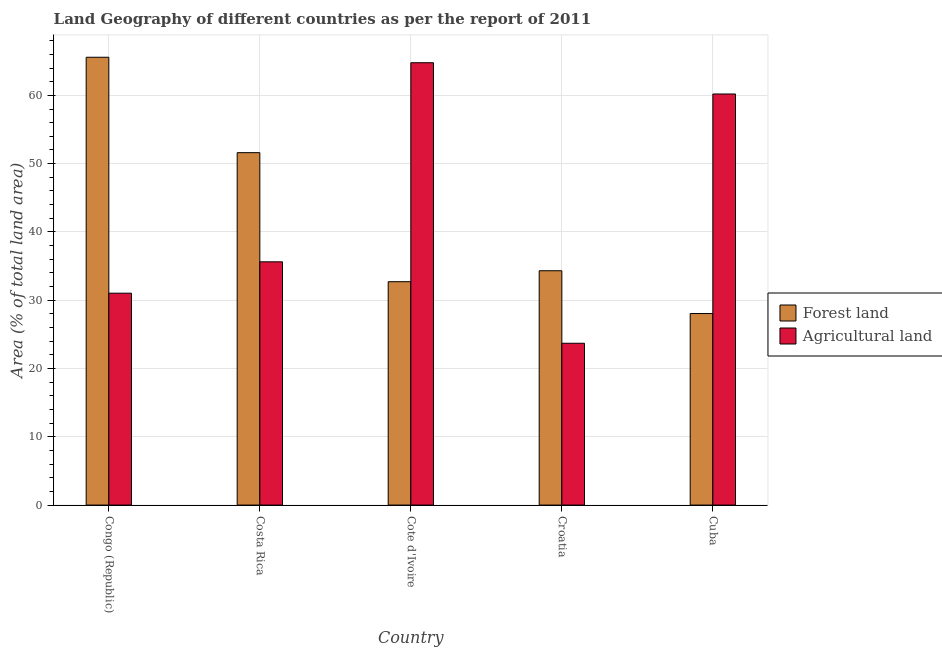How many groups of bars are there?
Give a very brief answer. 5. Are the number of bars per tick equal to the number of legend labels?
Offer a terse response. Yes. Are the number of bars on each tick of the X-axis equal?
Your answer should be very brief. Yes. How many bars are there on the 1st tick from the right?
Offer a terse response. 2. In how many cases, is the number of bars for a given country not equal to the number of legend labels?
Ensure brevity in your answer.  0. What is the percentage of land area under agriculture in Cote d'Ivoire?
Give a very brief answer. 64.78. Across all countries, what is the maximum percentage of land area under forests?
Your response must be concise. 65.58. Across all countries, what is the minimum percentage of land area under agriculture?
Offer a terse response. 23.7. In which country was the percentage of land area under forests maximum?
Give a very brief answer. Congo (Republic). In which country was the percentage of land area under agriculture minimum?
Provide a short and direct response. Croatia. What is the total percentage of land area under forests in the graph?
Provide a succinct answer. 212.27. What is the difference between the percentage of land area under agriculture in Congo (Republic) and that in Cuba?
Keep it short and to the point. -29.17. What is the difference between the percentage of land area under agriculture in Cuba and the percentage of land area under forests in Costa Rica?
Your answer should be compact. 8.59. What is the average percentage of land area under agriculture per country?
Make the answer very short. 43.07. What is the difference between the percentage of land area under forests and percentage of land area under agriculture in Congo (Republic)?
Make the answer very short. 34.55. What is the ratio of the percentage of land area under agriculture in Congo (Republic) to that in Croatia?
Offer a terse response. 1.31. Is the percentage of land area under agriculture in Congo (Republic) less than that in Costa Rica?
Keep it short and to the point. Yes. What is the difference between the highest and the second highest percentage of land area under agriculture?
Your response must be concise. 4.58. What is the difference between the highest and the lowest percentage of land area under agriculture?
Offer a terse response. 41.08. In how many countries, is the percentage of land area under forests greater than the average percentage of land area under forests taken over all countries?
Provide a short and direct response. 2. What does the 2nd bar from the left in Congo (Republic) represents?
Offer a terse response. Agricultural land. What does the 2nd bar from the right in Congo (Republic) represents?
Provide a succinct answer. Forest land. How many countries are there in the graph?
Your response must be concise. 5. What is the difference between two consecutive major ticks on the Y-axis?
Offer a very short reply. 10. Are the values on the major ticks of Y-axis written in scientific E-notation?
Provide a succinct answer. No. Does the graph contain any zero values?
Make the answer very short. No. Does the graph contain grids?
Make the answer very short. Yes. Where does the legend appear in the graph?
Make the answer very short. Center right. What is the title of the graph?
Give a very brief answer. Land Geography of different countries as per the report of 2011. Does "RDB concessional" appear as one of the legend labels in the graph?
Offer a terse response. No. What is the label or title of the X-axis?
Make the answer very short. Country. What is the label or title of the Y-axis?
Your answer should be very brief. Area (% of total land area). What is the Area (% of total land area) of Forest land in Congo (Republic)?
Your answer should be compact. 65.58. What is the Area (% of total land area) of Agricultural land in Congo (Republic)?
Provide a short and direct response. 31.03. What is the Area (% of total land area) in Forest land in Costa Rica?
Keep it short and to the point. 51.61. What is the Area (% of total land area) in Agricultural land in Costa Rica?
Your response must be concise. 35.62. What is the Area (% of total land area) of Forest land in Cote d'Ivoire?
Your answer should be very brief. 32.71. What is the Area (% of total land area) in Agricultural land in Cote d'Ivoire?
Offer a terse response. 64.78. What is the Area (% of total land area) of Forest land in Croatia?
Your answer should be compact. 34.32. What is the Area (% of total land area) in Agricultural land in Croatia?
Your response must be concise. 23.7. What is the Area (% of total land area) in Forest land in Cuba?
Offer a terse response. 28.05. What is the Area (% of total land area) of Agricultural land in Cuba?
Keep it short and to the point. 60.2. Across all countries, what is the maximum Area (% of total land area) of Forest land?
Provide a short and direct response. 65.58. Across all countries, what is the maximum Area (% of total land area) in Agricultural land?
Give a very brief answer. 64.78. Across all countries, what is the minimum Area (% of total land area) in Forest land?
Ensure brevity in your answer.  28.05. Across all countries, what is the minimum Area (% of total land area) of Agricultural land?
Your response must be concise. 23.7. What is the total Area (% of total land area) of Forest land in the graph?
Your answer should be very brief. 212.27. What is the total Area (% of total land area) of Agricultural land in the graph?
Provide a short and direct response. 215.33. What is the difference between the Area (% of total land area) of Forest land in Congo (Republic) and that in Costa Rica?
Provide a succinct answer. 13.97. What is the difference between the Area (% of total land area) of Agricultural land in Congo (Republic) and that in Costa Rica?
Provide a short and direct response. -4.6. What is the difference between the Area (% of total land area) in Forest land in Congo (Republic) and that in Cote d'Ivoire?
Your answer should be compact. 32.87. What is the difference between the Area (% of total land area) in Agricultural land in Congo (Republic) and that in Cote d'Ivoire?
Your answer should be very brief. -33.75. What is the difference between the Area (% of total land area) of Forest land in Congo (Republic) and that in Croatia?
Offer a terse response. 31.26. What is the difference between the Area (% of total land area) of Agricultural land in Congo (Republic) and that in Croatia?
Make the answer very short. 7.33. What is the difference between the Area (% of total land area) of Forest land in Congo (Republic) and that in Cuba?
Ensure brevity in your answer.  37.53. What is the difference between the Area (% of total land area) in Agricultural land in Congo (Republic) and that in Cuba?
Provide a succinct answer. -29.17. What is the difference between the Area (% of total land area) in Forest land in Costa Rica and that in Cote d'Ivoire?
Provide a short and direct response. 18.9. What is the difference between the Area (% of total land area) of Agricultural land in Costa Rica and that in Cote d'Ivoire?
Make the answer very short. -29.16. What is the difference between the Area (% of total land area) in Forest land in Costa Rica and that in Croatia?
Ensure brevity in your answer.  17.29. What is the difference between the Area (% of total land area) of Agricultural land in Costa Rica and that in Croatia?
Keep it short and to the point. 11.93. What is the difference between the Area (% of total land area) in Forest land in Costa Rica and that in Cuba?
Your answer should be compact. 23.56. What is the difference between the Area (% of total land area) in Agricultural land in Costa Rica and that in Cuba?
Ensure brevity in your answer.  -24.58. What is the difference between the Area (% of total land area) of Forest land in Cote d'Ivoire and that in Croatia?
Make the answer very short. -1.6. What is the difference between the Area (% of total land area) in Agricultural land in Cote d'Ivoire and that in Croatia?
Provide a succinct answer. 41.08. What is the difference between the Area (% of total land area) in Forest land in Cote d'Ivoire and that in Cuba?
Offer a terse response. 4.66. What is the difference between the Area (% of total land area) in Agricultural land in Cote d'Ivoire and that in Cuba?
Offer a very short reply. 4.58. What is the difference between the Area (% of total land area) in Forest land in Croatia and that in Cuba?
Your answer should be compact. 6.27. What is the difference between the Area (% of total land area) in Agricultural land in Croatia and that in Cuba?
Offer a terse response. -36.5. What is the difference between the Area (% of total land area) of Forest land in Congo (Republic) and the Area (% of total land area) of Agricultural land in Costa Rica?
Offer a terse response. 29.96. What is the difference between the Area (% of total land area) of Forest land in Congo (Republic) and the Area (% of total land area) of Agricultural land in Cote d'Ivoire?
Your answer should be compact. 0.8. What is the difference between the Area (% of total land area) of Forest land in Congo (Republic) and the Area (% of total land area) of Agricultural land in Croatia?
Offer a very short reply. 41.88. What is the difference between the Area (% of total land area) of Forest land in Congo (Republic) and the Area (% of total land area) of Agricultural land in Cuba?
Provide a short and direct response. 5.38. What is the difference between the Area (% of total land area) of Forest land in Costa Rica and the Area (% of total land area) of Agricultural land in Cote d'Ivoire?
Provide a short and direct response. -13.17. What is the difference between the Area (% of total land area) in Forest land in Costa Rica and the Area (% of total land area) in Agricultural land in Croatia?
Ensure brevity in your answer.  27.91. What is the difference between the Area (% of total land area) of Forest land in Costa Rica and the Area (% of total land area) of Agricultural land in Cuba?
Your response must be concise. -8.59. What is the difference between the Area (% of total land area) in Forest land in Cote d'Ivoire and the Area (% of total land area) in Agricultural land in Croatia?
Ensure brevity in your answer.  9.02. What is the difference between the Area (% of total land area) in Forest land in Cote d'Ivoire and the Area (% of total land area) in Agricultural land in Cuba?
Your response must be concise. -27.49. What is the difference between the Area (% of total land area) in Forest land in Croatia and the Area (% of total land area) in Agricultural land in Cuba?
Ensure brevity in your answer.  -25.88. What is the average Area (% of total land area) of Forest land per country?
Give a very brief answer. 42.45. What is the average Area (% of total land area) in Agricultural land per country?
Your response must be concise. 43.07. What is the difference between the Area (% of total land area) of Forest land and Area (% of total land area) of Agricultural land in Congo (Republic)?
Offer a terse response. 34.55. What is the difference between the Area (% of total land area) of Forest land and Area (% of total land area) of Agricultural land in Costa Rica?
Ensure brevity in your answer.  15.99. What is the difference between the Area (% of total land area) in Forest land and Area (% of total land area) in Agricultural land in Cote d'Ivoire?
Provide a succinct answer. -32.07. What is the difference between the Area (% of total land area) in Forest land and Area (% of total land area) in Agricultural land in Croatia?
Offer a terse response. 10.62. What is the difference between the Area (% of total land area) of Forest land and Area (% of total land area) of Agricultural land in Cuba?
Give a very brief answer. -32.15. What is the ratio of the Area (% of total land area) of Forest land in Congo (Republic) to that in Costa Rica?
Ensure brevity in your answer.  1.27. What is the ratio of the Area (% of total land area) in Agricultural land in Congo (Republic) to that in Costa Rica?
Give a very brief answer. 0.87. What is the ratio of the Area (% of total land area) of Forest land in Congo (Republic) to that in Cote d'Ivoire?
Give a very brief answer. 2. What is the ratio of the Area (% of total land area) in Agricultural land in Congo (Republic) to that in Cote d'Ivoire?
Your response must be concise. 0.48. What is the ratio of the Area (% of total land area) of Forest land in Congo (Republic) to that in Croatia?
Give a very brief answer. 1.91. What is the ratio of the Area (% of total land area) in Agricultural land in Congo (Republic) to that in Croatia?
Provide a succinct answer. 1.31. What is the ratio of the Area (% of total land area) in Forest land in Congo (Republic) to that in Cuba?
Offer a terse response. 2.34. What is the ratio of the Area (% of total land area) of Agricultural land in Congo (Republic) to that in Cuba?
Provide a short and direct response. 0.52. What is the ratio of the Area (% of total land area) in Forest land in Costa Rica to that in Cote d'Ivoire?
Give a very brief answer. 1.58. What is the ratio of the Area (% of total land area) of Agricultural land in Costa Rica to that in Cote d'Ivoire?
Offer a very short reply. 0.55. What is the ratio of the Area (% of total land area) in Forest land in Costa Rica to that in Croatia?
Provide a succinct answer. 1.5. What is the ratio of the Area (% of total land area) of Agricultural land in Costa Rica to that in Croatia?
Your answer should be very brief. 1.5. What is the ratio of the Area (% of total land area) of Forest land in Costa Rica to that in Cuba?
Keep it short and to the point. 1.84. What is the ratio of the Area (% of total land area) of Agricultural land in Costa Rica to that in Cuba?
Give a very brief answer. 0.59. What is the ratio of the Area (% of total land area) of Forest land in Cote d'Ivoire to that in Croatia?
Your answer should be compact. 0.95. What is the ratio of the Area (% of total land area) of Agricultural land in Cote d'Ivoire to that in Croatia?
Provide a succinct answer. 2.73. What is the ratio of the Area (% of total land area) in Forest land in Cote d'Ivoire to that in Cuba?
Keep it short and to the point. 1.17. What is the ratio of the Area (% of total land area) of Agricultural land in Cote d'Ivoire to that in Cuba?
Your answer should be compact. 1.08. What is the ratio of the Area (% of total land area) in Forest land in Croatia to that in Cuba?
Keep it short and to the point. 1.22. What is the ratio of the Area (% of total land area) in Agricultural land in Croatia to that in Cuba?
Make the answer very short. 0.39. What is the difference between the highest and the second highest Area (% of total land area) of Forest land?
Make the answer very short. 13.97. What is the difference between the highest and the second highest Area (% of total land area) of Agricultural land?
Your response must be concise. 4.58. What is the difference between the highest and the lowest Area (% of total land area) in Forest land?
Keep it short and to the point. 37.53. What is the difference between the highest and the lowest Area (% of total land area) of Agricultural land?
Give a very brief answer. 41.08. 